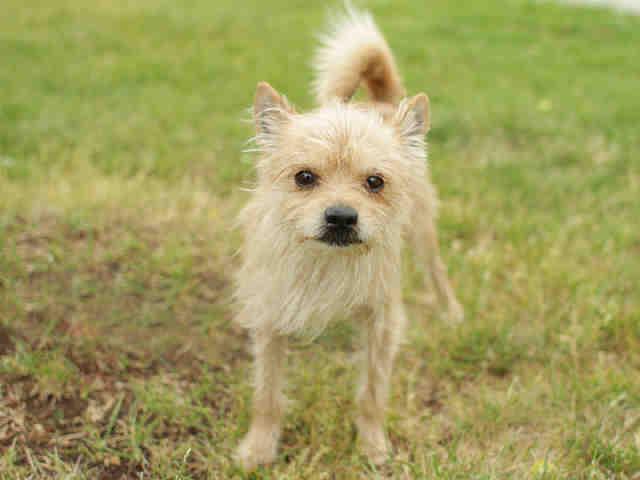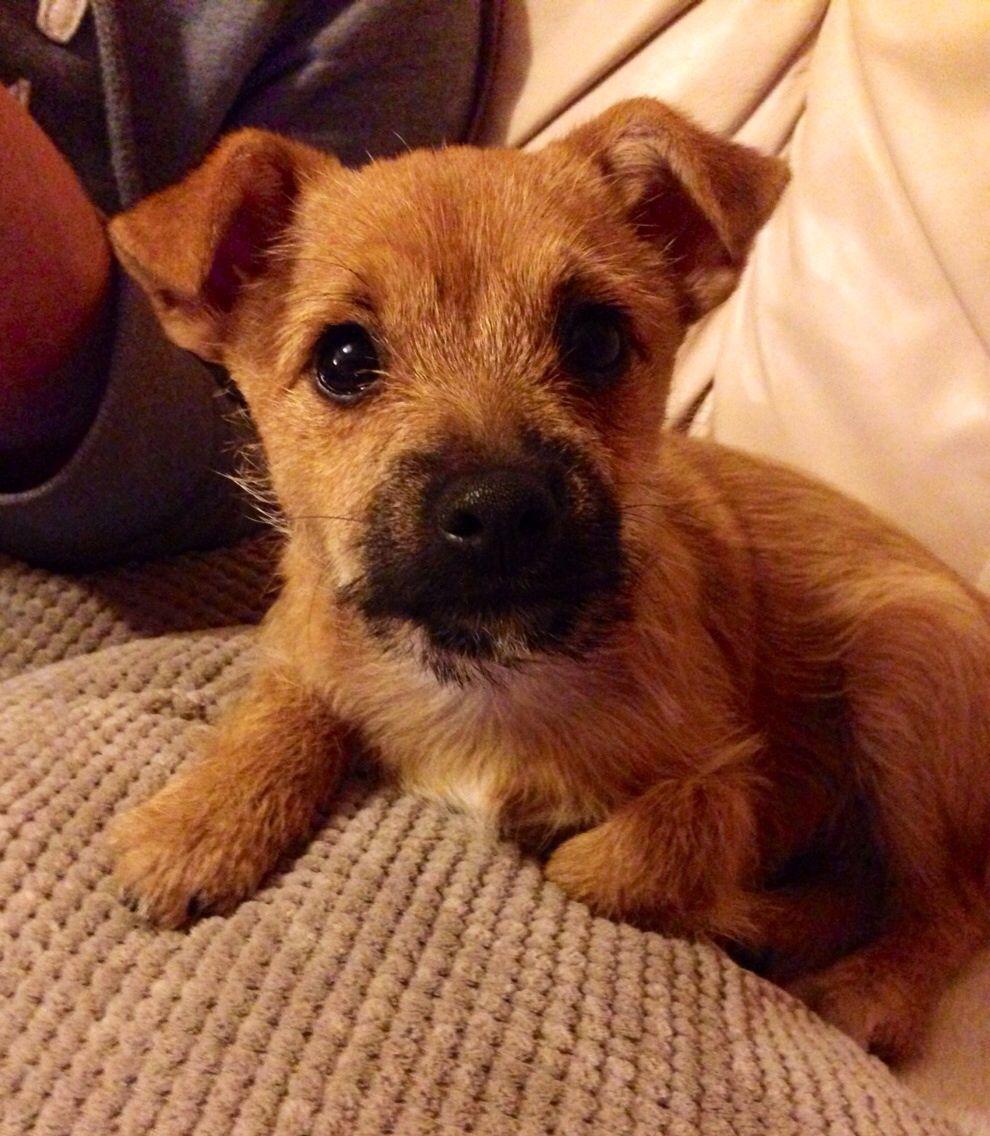The first image is the image on the left, the second image is the image on the right. For the images shown, is this caption "One image shows a dog whose mouth isn't fully closed." true? Answer yes or no. No. The first image is the image on the left, the second image is the image on the right. For the images displayed, is the sentence "One of the dogs has a body part that is normally inside the mouth being shown outside of the mouth." factually correct? Answer yes or no. No. 